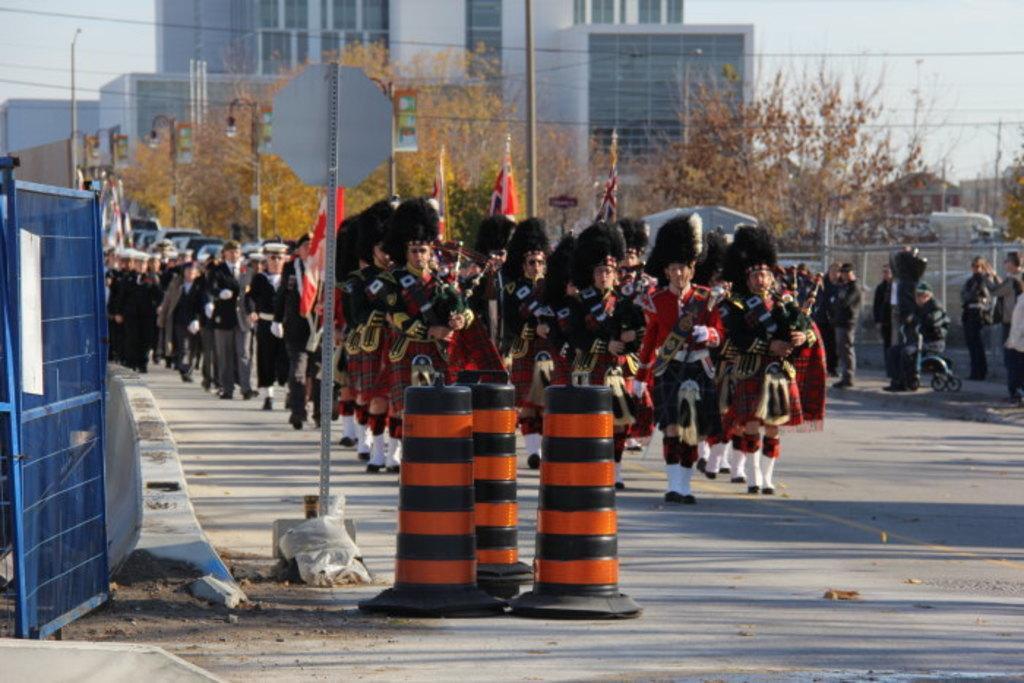Please provide a concise description of this image. In this image, there are a few people. We can see the ground with some objects. There are a few trees and poles. We can see a blue colored object on the left. We can see the wall. We can see some houses, flags and wires. We can also see some vehicles and the sky. 